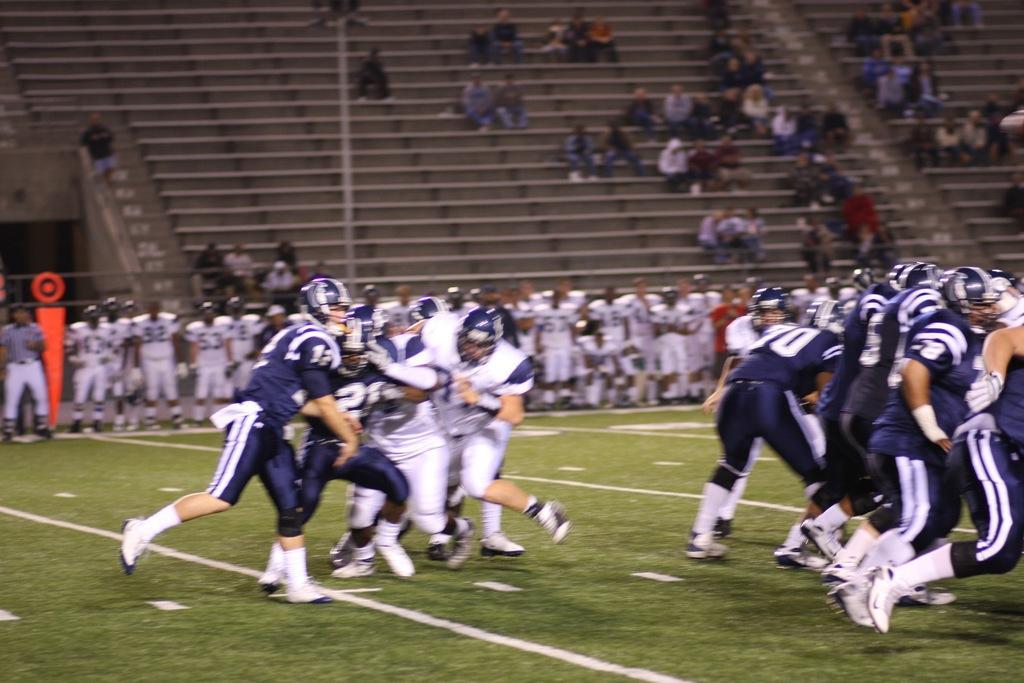Please provide a concise description of this image. In the center of the image we can see some people are playing and wearing the spots dresses, shoes, helmets. On the right side of the image we can see some people are playing. In the background of the image we can see a group of people are standing and also we can see a pole, board, some people are sitting on the stairs. At the bottom of the image we can see the ground. 